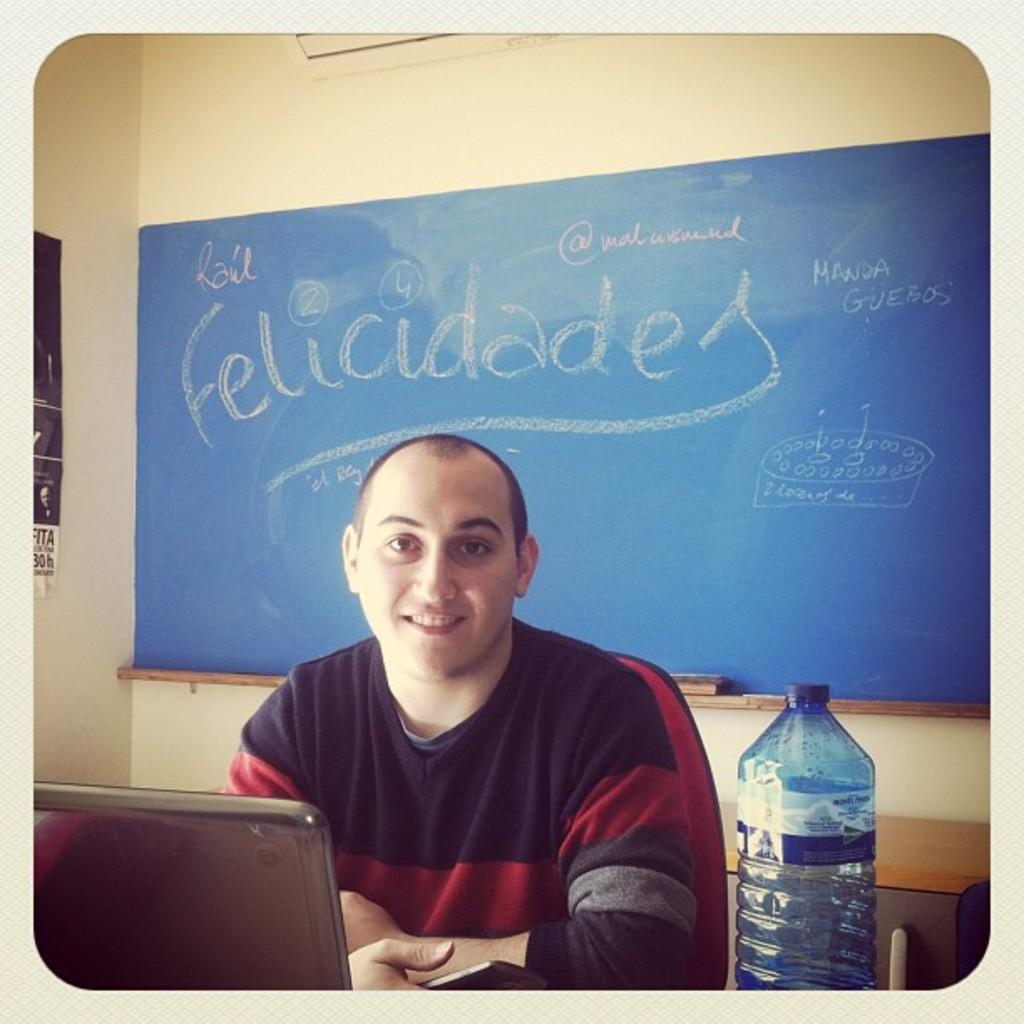What is the man in the image doing? The man is sitting on a chair in the image. What object is in front of the man? There is a laptop and a bottle in front of the man. What is on the wall behind the man? There is a board with something written on it, and a wall behind the board. What type of soda is in the basket next to the man? There is no basket or soda present in the image. 